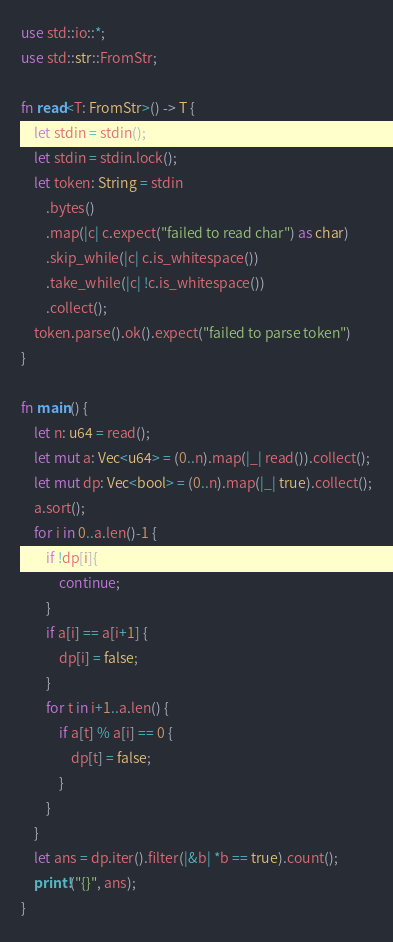Convert code to text. <code><loc_0><loc_0><loc_500><loc_500><_Rust_>use std::io::*;
use std::str::FromStr;

fn read<T: FromStr>() -> T {
    let stdin = stdin();
    let stdin = stdin.lock();
    let token: String = stdin
        .bytes()
        .map(|c| c.expect("failed to read char") as char)
        .skip_while(|c| c.is_whitespace())
        .take_while(|c| !c.is_whitespace())
        .collect();
    token.parse().ok().expect("failed to parse token")
}

fn main() {
    let n: u64 = read();
    let mut a: Vec<u64> = (0..n).map(|_| read()).collect();
    let mut dp: Vec<bool> = (0..n).map(|_| true).collect();
    a.sort();
    for i in 0..a.len()-1 {
        if !dp[i]{
            continue;
        }
        if a[i] == a[i+1] {
            dp[i] = false;
        }
        for t in i+1..a.len() {
            if a[t] % a[i] == 0 {
                dp[t] = false;
            }
        }
    }
    let ans = dp.iter().filter(|&b| *b == true).count();
    print!("{}", ans);
}
</code> 